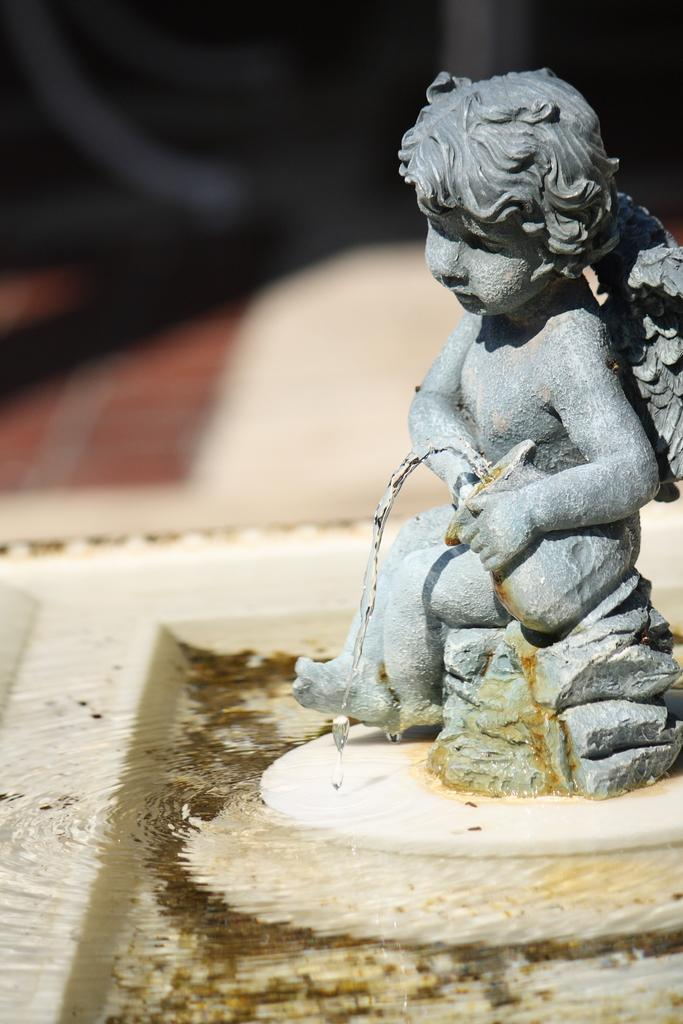Where was the image taken? The image was taken outdoors. What can be seen at the bottom of the image? There is a fountain at the bottom of the image. What is located on the right side of the image? There is a sculpture on the right side of the image. What type of book is being held by the sculpture in the image? There is no book present in the image, as the main subject on the right side is a sculpture, not a person holding a book. 